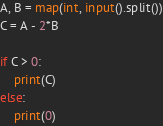Convert code to text. <code><loc_0><loc_0><loc_500><loc_500><_Python_>A, B = map(int, input().split())
C = A - 2*B

if C > 0:
    print(C)
else:
    print(0)</code> 